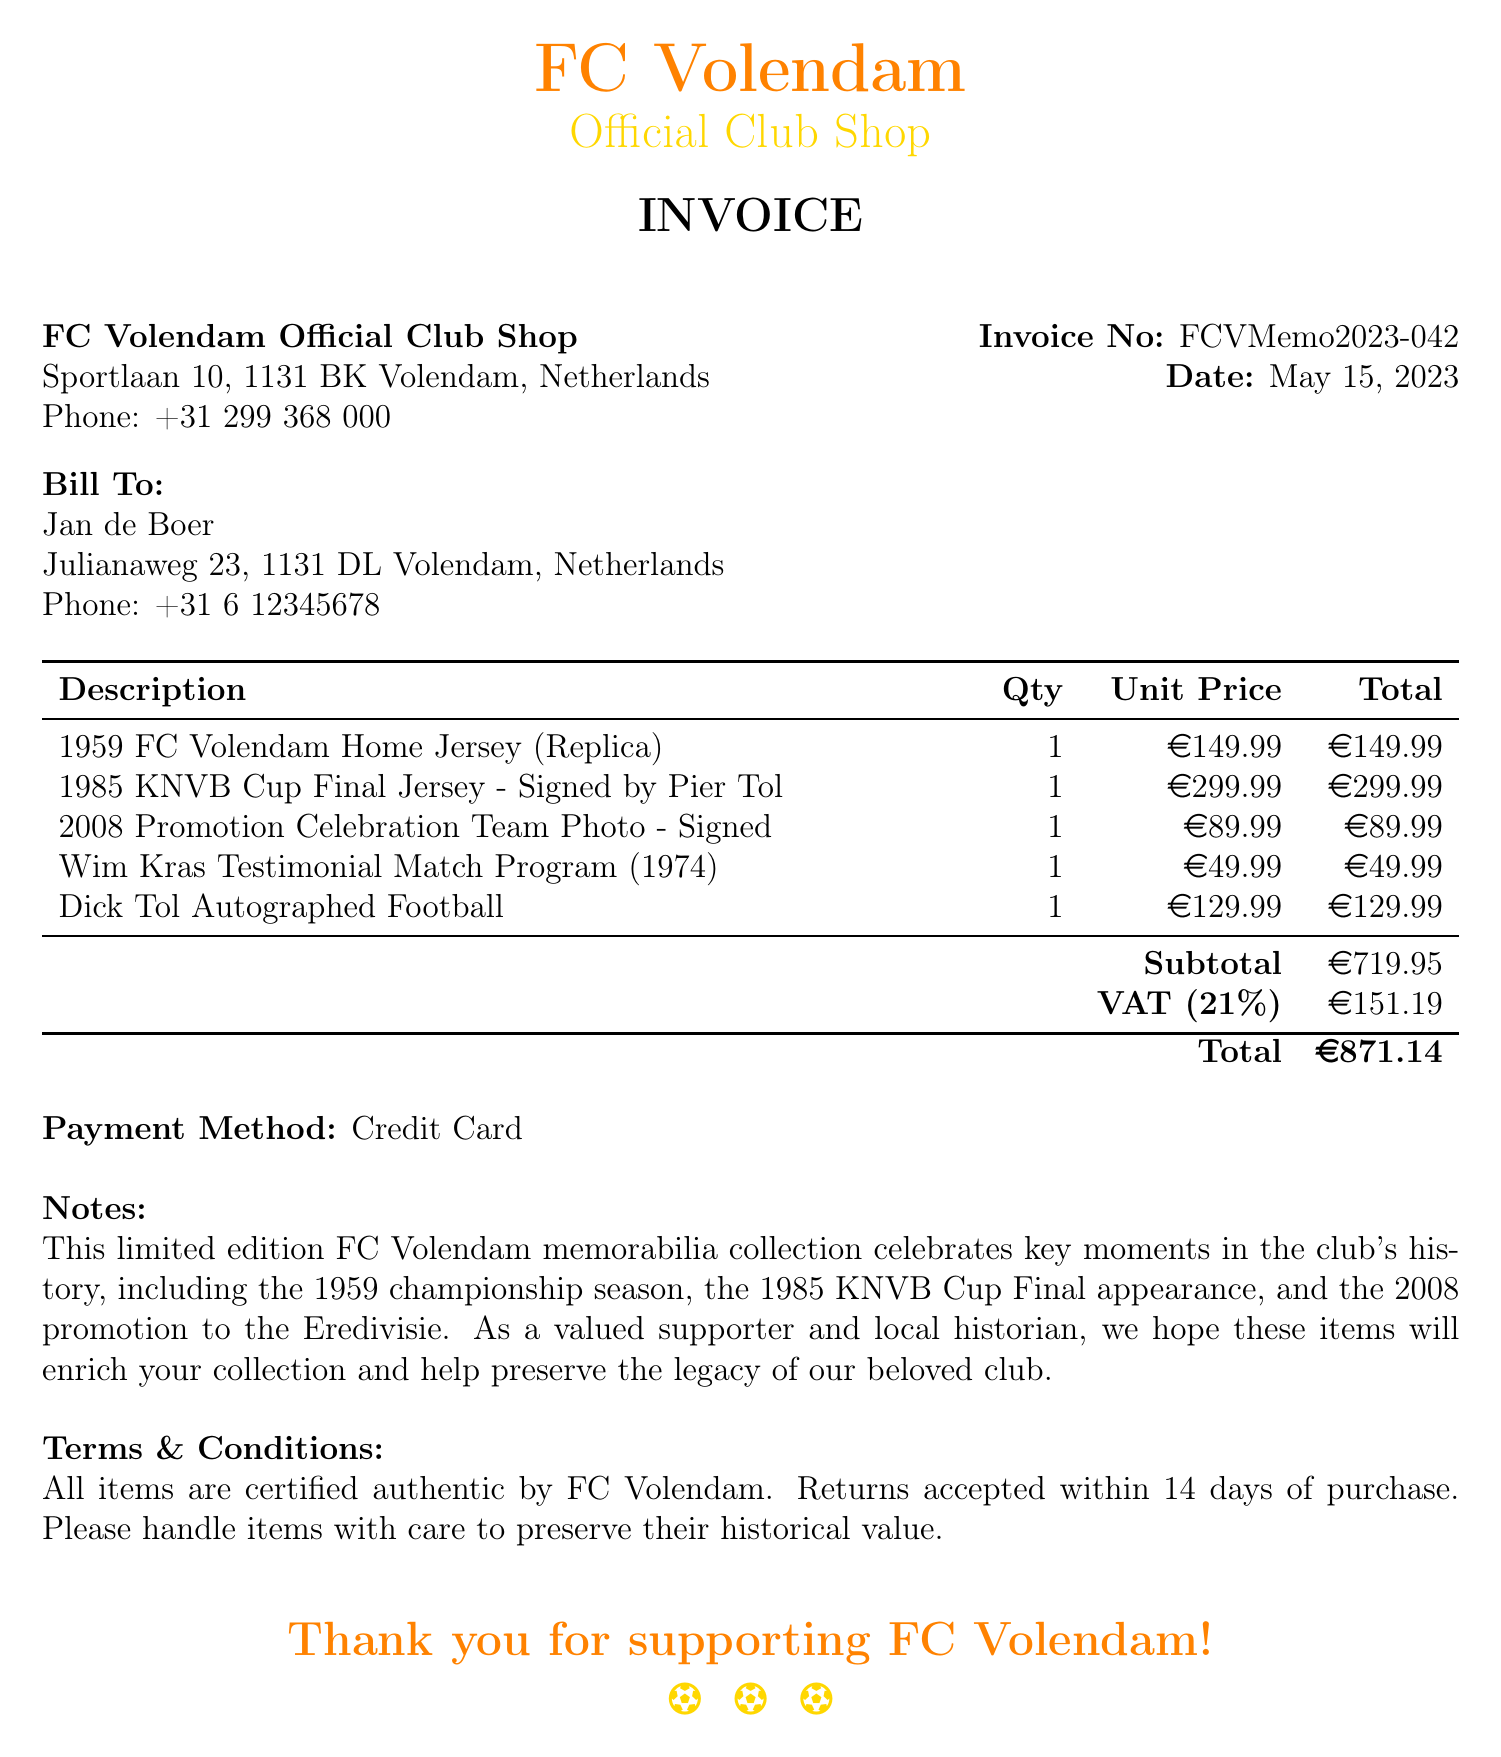What is the invoice number? The invoice number is clearly stated in the document as a unique identifier for this transaction.
Answer: FCVMemo2023-042 Who is the seller? The seller's information, including name and address, is provided at the top of the invoice.
Answer: FC Volendam Official Club Shop What is the date of the invoice? The date is marked on the invoice and is significant for record-keeping and payment terms.
Answer: May 15, 2023 What is the total amount due? The total amount is specified at the end of the invoice, summarizing the subtotals and taxes involved.
Answer: €871.14 What item is signed by Pier Tol? This item is noted in the items list, requiring knowledge of the event and the signature.
Answer: 1985 KNVB Cup Final Jersey - Signed by Pier Tol How much was paid for the Dick Tol Autographed Football? The price is listed next to the description and is relevant for assessing the total purchase cost.
Answer: €129.99 What is the VAT amount? The VAT amount is explicitly stated to provide clarity on taxes applied to the purchase.
Answer: €151.19 What payment method was used? The payment method is provided near the bottom of the invoice, reflecting how the transaction was completed.
Answer: Credit Card What is stated in the notes section? The notes section contains important context about the items purchased, enhancing their significance for the buyer.
Answer: This limited edition FC Volendam memorabilia collection celebrates key moments in the club's history.. 